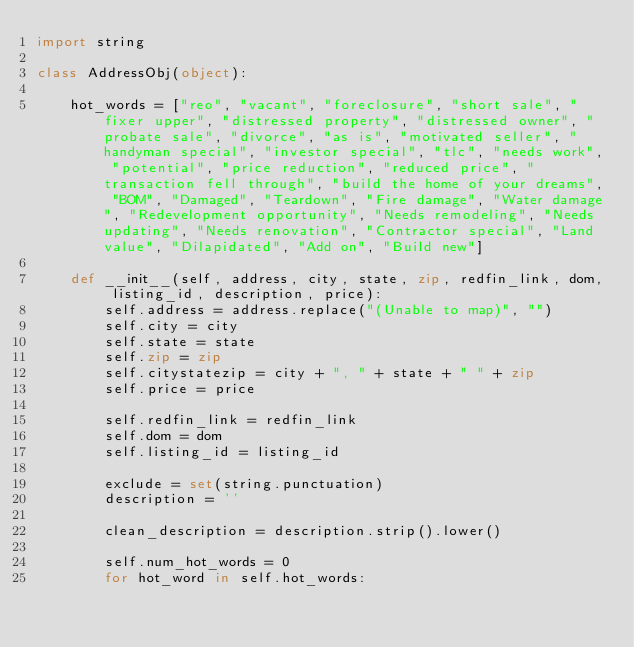<code> <loc_0><loc_0><loc_500><loc_500><_Python_>import string

class AddressObj(object):
    
    hot_words = ["reo", "vacant", "foreclosure", "short sale", "fixer upper", "distressed property", "distressed owner", "probate sale", "divorce", "as is", "motivated seller", "handyman special", "investor special", "tlc", "needs work", "potential", "price reduction", "reduced price", "transaction fell through", "build the home of your dreams", "BOM", "Damaged", "Teardown", "Fire damage", "Water damage", "Redevelopment opportunity", "Needs remodeling", "Needs updating", "Needs renovation", "Contractor special", "Land value", "Dilapidated", "Add on", "Build new"]

    def __init__(self, address, city, state, zip, redfin_link, dom, listing_id, description, price):
        self.address = address.replace("(Unable to map)", "")
        self.city = city
        self.state = state
        self.zip = zip
        self.citystatezip = city + ", " + state + " " + zip
        self.price = price

        self.redfin_link = redfin_link
        self.dom = dom
        self.listing_id = listing_id

        exclude = set(string.punctuation)
        description = ''

        clean_description = description.strip().lower()

        self.num_hot_words = 0
        for hot_word in self.hot_words:</code> 